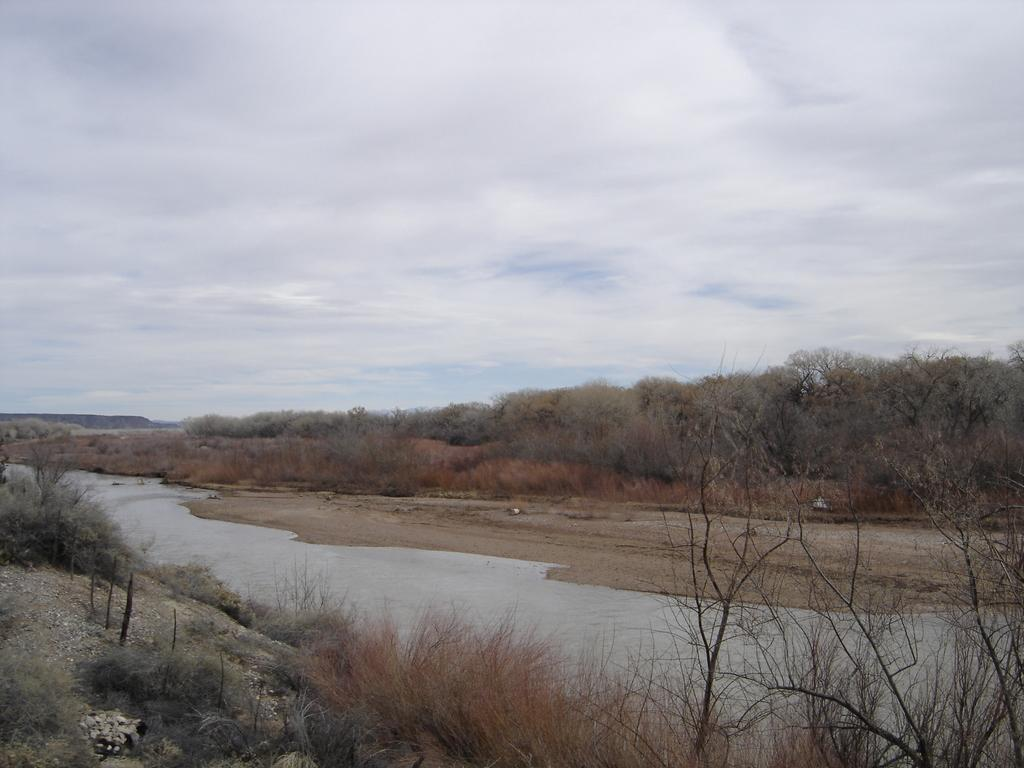What types of terrain are visible in the foreground of the image? There is grass and sand in the foreground of the image. What is the main feature in the middle of the image? There is a water body and sand in the middle of the image. What type of vegetation is present in the middle of the image? There are trees in the middle of the image. What type of plastic is being used to build the son's toy in the image? There is no plastic or son present in the image. 